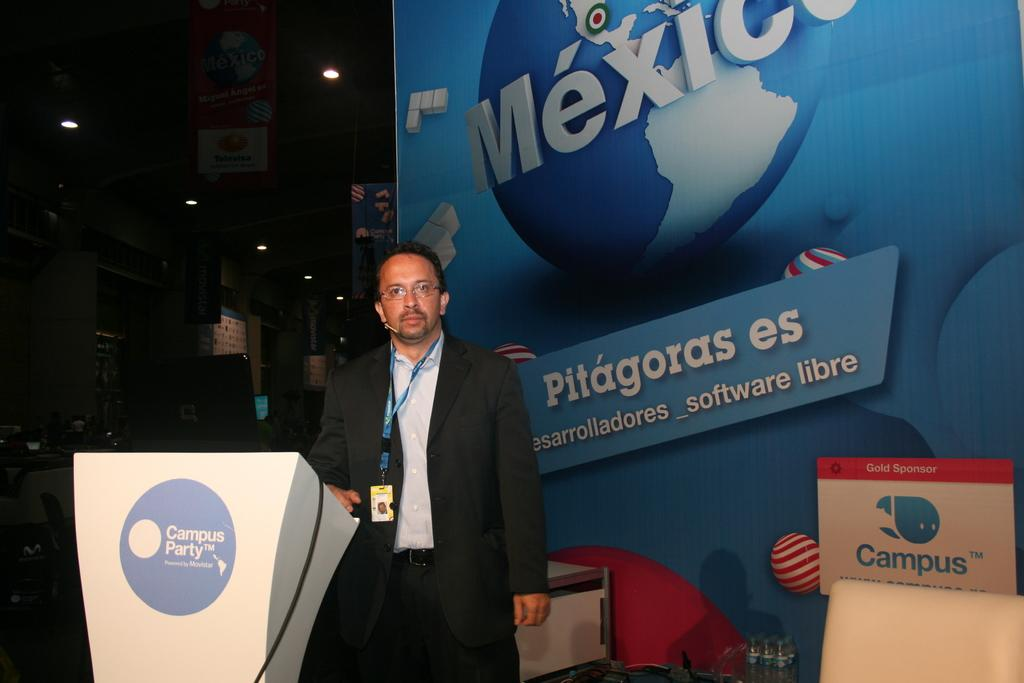Who or what is the main subject in the image? There is a person in the image. What is the person standing in front of? The person is in front of a banner. Can you describe what the person is wearing? The person is wearing an ID card. What other objects or structures can be seen in the image? There is a podium in the bottom left of the image, and there are lights on the ceiling. What type of pot is being used to celebrate the person's birthday in the image? There is no pot or birthday celebration present in the image. How does the person plan to change their outfit during the event? The image does not provide information about the person changing their outfit or any event taking place. 